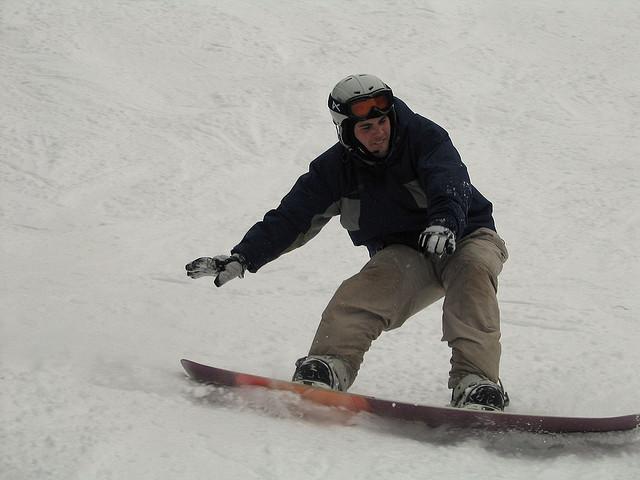Is the man young?
Give a very brief answer. Yes. Do you think the guy is feeling cold?
Quick response, please. Yes. How fast is the man going?
Concise answer only. Fast. Are there trees in this picture?
Write a very short answer. No. Is the snowboarder smiling?
Be succinct. Yes. Is the man wearing sunglasses?
Give a very brief answer. No. Where are the goggles?
Give a very brief answer. Helmet. Is the man making a peace sign?
Answer briefly. No. 